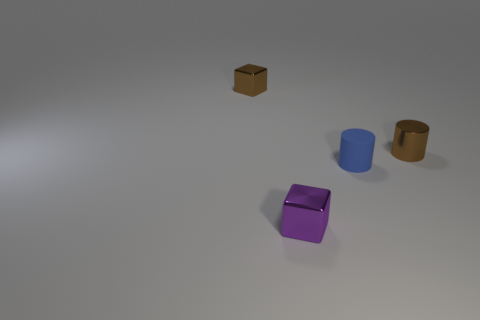Do the metal cylinder and the small metallic block behind the tiny brown cylinder have the same color?
Offer a very short reply. Yes. What material is the block that is the same color as the shiny cylinder?
Your answer should be very brief. Metal. Is the number of yellow matte cylinders less than the number of small purple cubes?
Give a very brief answer. Yes. Are there more purple shiny things than small gray shiny cylinders?
Your answer should be compact. Yes. How many other objects are there of the same color as the small matte thing?
Your response must be concise. 0. How many tiny brown blocks are in front of the tiny metal cube in front of the tiny brown cylinder?
Ensure brevity in your answer.  0. There is a tiny rubber thing; are there any small metal cubes behind it?
Your response must be concise. Yes. There is a small brown thing in front of the cube that is behind the tiny purple shiny cube; what shape is it?
Give a very brief answer. Cylinder. Is the number of tiny shiny cubes behind the blue rubber cylinder less than the number of small things in front of the brown cylinder?
Your answer should be very brief. Yes. There is another small metal thing that is the same shape as the blue thing; what color is it?
Your answer should be compact. Brown. 